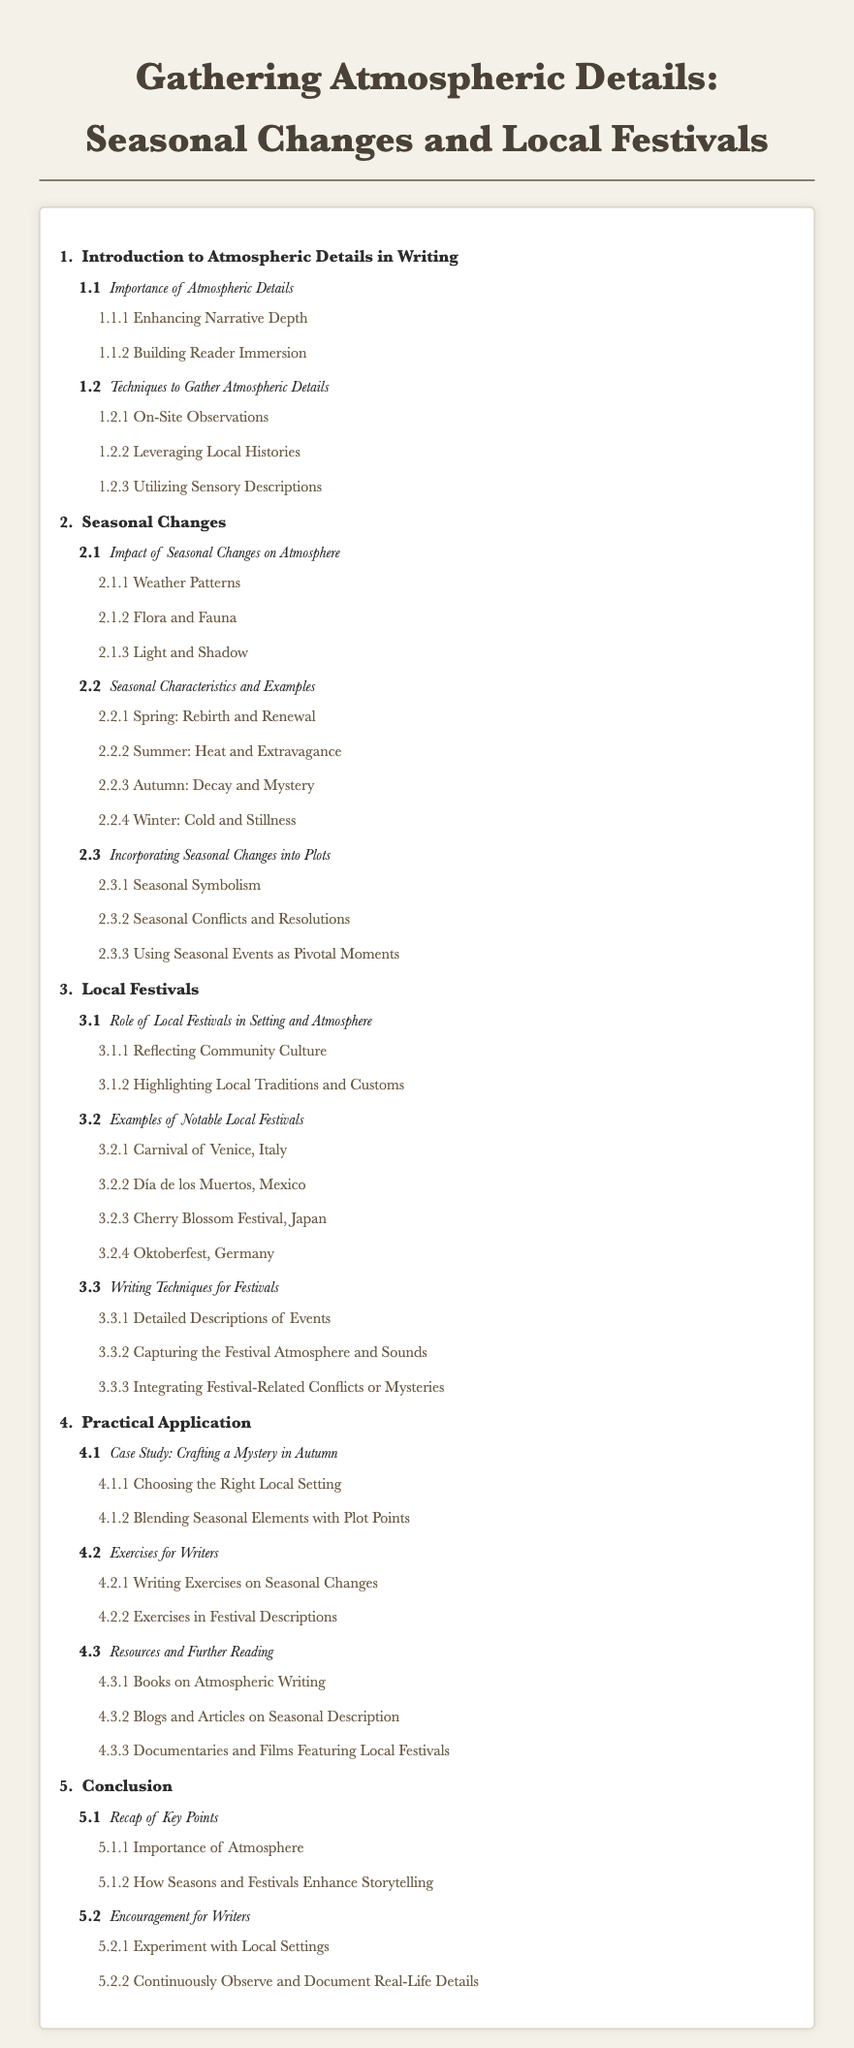What is the main title of the document? The title is prominently displayed at the top of the document and is "Gathering Atmospheric Details: Seasonal Changes and Local Festivals."
Answer: Gathering Atmospheric Details: Seasonal Changes and Local Festivals How many sections are there in the table of contents? The number of the main sections is indicated by the numerals listed at the beginning of each section. There are five sections.
Answer: 5 What is the subchapter under Section 3 titled? The subchapters are listed under each main chapter, and one of them under Section 3 is "Examples of Notable Local Festivals."
Answer: Examples of Notable Local Festivals Which season is associated with "Decay and Mystery"? The title for Spring, Summer, Autumn, and Winter is provided under seasonal characteristics, where Autumn is linked to "Decay and Mystery."
Answer: Autumn What techniques are suggested for gathering atmospheric details? Techniques are listed under Section 1.2, which suggests three methods, including "Utilizing Sensory Descriptions."
Answer: Utilizing Sensory Descriptions How many notable local festivals are highlighted in Section 3.2? The document specifies several examples, indicating there are four notable local festivals mentioned.
Answer: 4 What is the title of the case study in Section 4.1? The title of the case study is indicated under its respective section. It is "Crafting a Mystery in Autumn."
Answer: Crafting a Mystery in Autumn What is the focus of Section 5? The document outlines various parts, with Section 5 focusing on summarization and encouragement for writers, summarized under the title "Conclusion."
Answer: Conclusion 